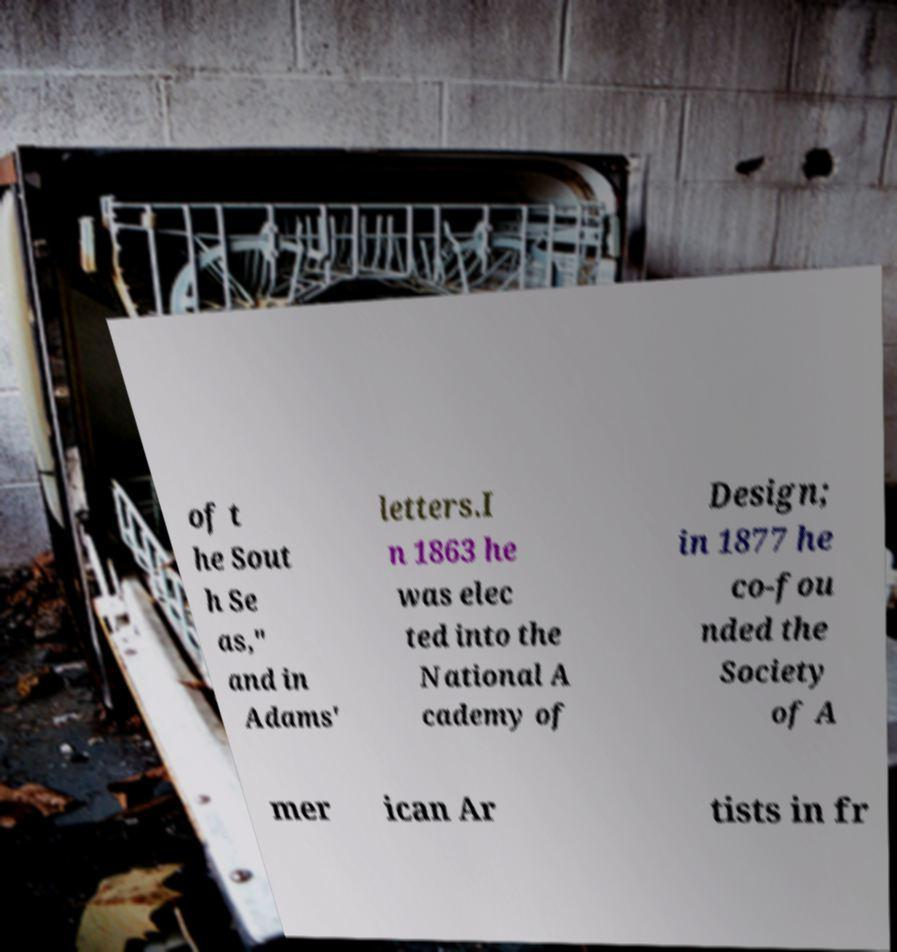There's text embedded in this image that I need extracted. Can you transcribe it verbatim? of t he Sout h Se as," and in Adams' letters.I n 1863 he was elec ted into the National A cademy of Design; in 1877 he co-fou nded the Society of A mer ican Ar tists in fr 